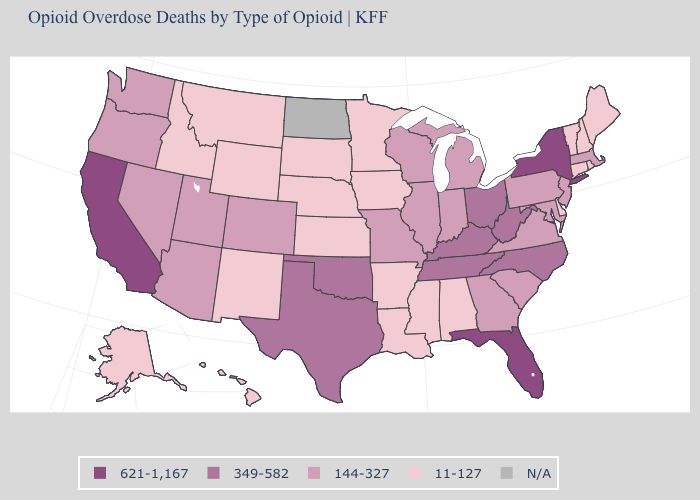What is the highest value in the USA?
Give a very brief answer. 621-1,167. Name the states that have a value in the range 349-582?
Short answer required. Kentucky, North Carolina, Ohio, Oklahoma, Tennessee, Texas, West Virginia. What is the value of South Carolina?
Answer briefly. 144-327. Name the states that have a value in the range 11-127?
Write a very short answer. Alabama, Alaska, Arkansas, Connecticut, Delaware, Hawaii, Idaho, Iowa, Kansas, Louisiana, Maine, Minnesota, Mississippi, Montana, Nebraska, New Hampshire, New Mexico, Rhode Island, South Dakota, Vermont, Wyoming. Does Ohio have the highest value in the MidWest?
Keep it brief. Yes. Among the states that border Illinois , which have the lowest value?
Concise answer only. Iowa. How many symbols are there in the legend?
Write a very short answer. 5. What is the value of Wyoming?
Answer briefly. 11-127. What is the value of Idaho?
Give a very brief answer. 11-127. What is the lowest value in the USA?
Concise answer only. 11-127. Name the states that have a value in the range 349-582?
Answer briefly. Kentucky, North Carolina, Ohio, Oklahoma, Tennessee, Texas, West Virginia. Does California have the highest value in the USA?
Be succinct. Yes. Among the states that border Kansas , does Missouri have the lowest value?
Quick response, please. No. 